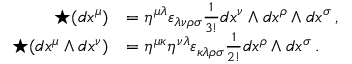Convert formula to latex. <formula><loc_0><loc_0><loc_500><loc_500>{ \begin{array} { r l } { ^ { * } ( d x ^ { \mu } ) } & { = \eta ^ { \mu \lambda } \varepsilon _ { \lambda \nu \rho \sigma } { \frac { 1 } { 3 ! } } d x ^ { \nu } \wedge d x ^ { \rho } \wedge d x ^ { \sigma } \, , } \\ { ^ { * } ( d x ^ { \mu } \wedge d x ^ { \nu } ) } & { = \eta ^ { \mu \kappa } \eta ^ { \nu \lambda } \varepsilon _ { \kappa \lambda \rho \sigma } { \frac { 1 } { 2 ! } } d x ^ { \rho } \wedge d x ^ { \sigma } \, . } \end{array} }</formula> 